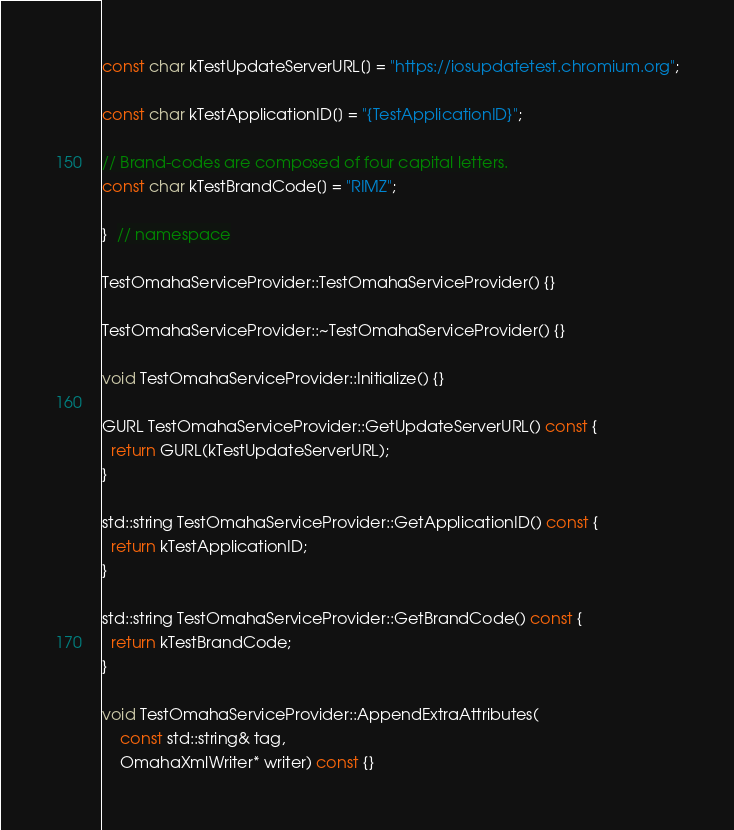Convert code to text. <code><loc_0><loc_0><loc_500><loc_500><_ObjectiveC_>
const char kTestUpdateServerURL[] = "https://iosupdatetest.chromium.org";

const char kTestApplicationID[] = "{TestApplicationID}";

// Brand-codes are composed of four capital letters.
const char kTestBrandCode[] = "RIMZ";

}  // namespace

TestOmahaServiceProvider::TestOmahaServiceProvider() {}

TestOmahaServiceProvider::~TestOmahaServiceProvider() {}

void TestOmahaServiceProvider::Initialize() {}

GURL TestOmahaServiceProvider::GetUpdateServerURL() const {
  return GURL(kTestUpdateServerURL);
}

std::string TestOmahaServiceProvider::GetApplicationID() const {
  return kTestApplicationID;
}

std::string TestOmahaServiceProvider::GetBrandCode() const {
  return kTestBrandCode;
}

void TestOmahaServiceProvider::AppendExtraAttributes(
    const std::string& tag,
    OmahaXmlWriter* writer) const {}
</code> 